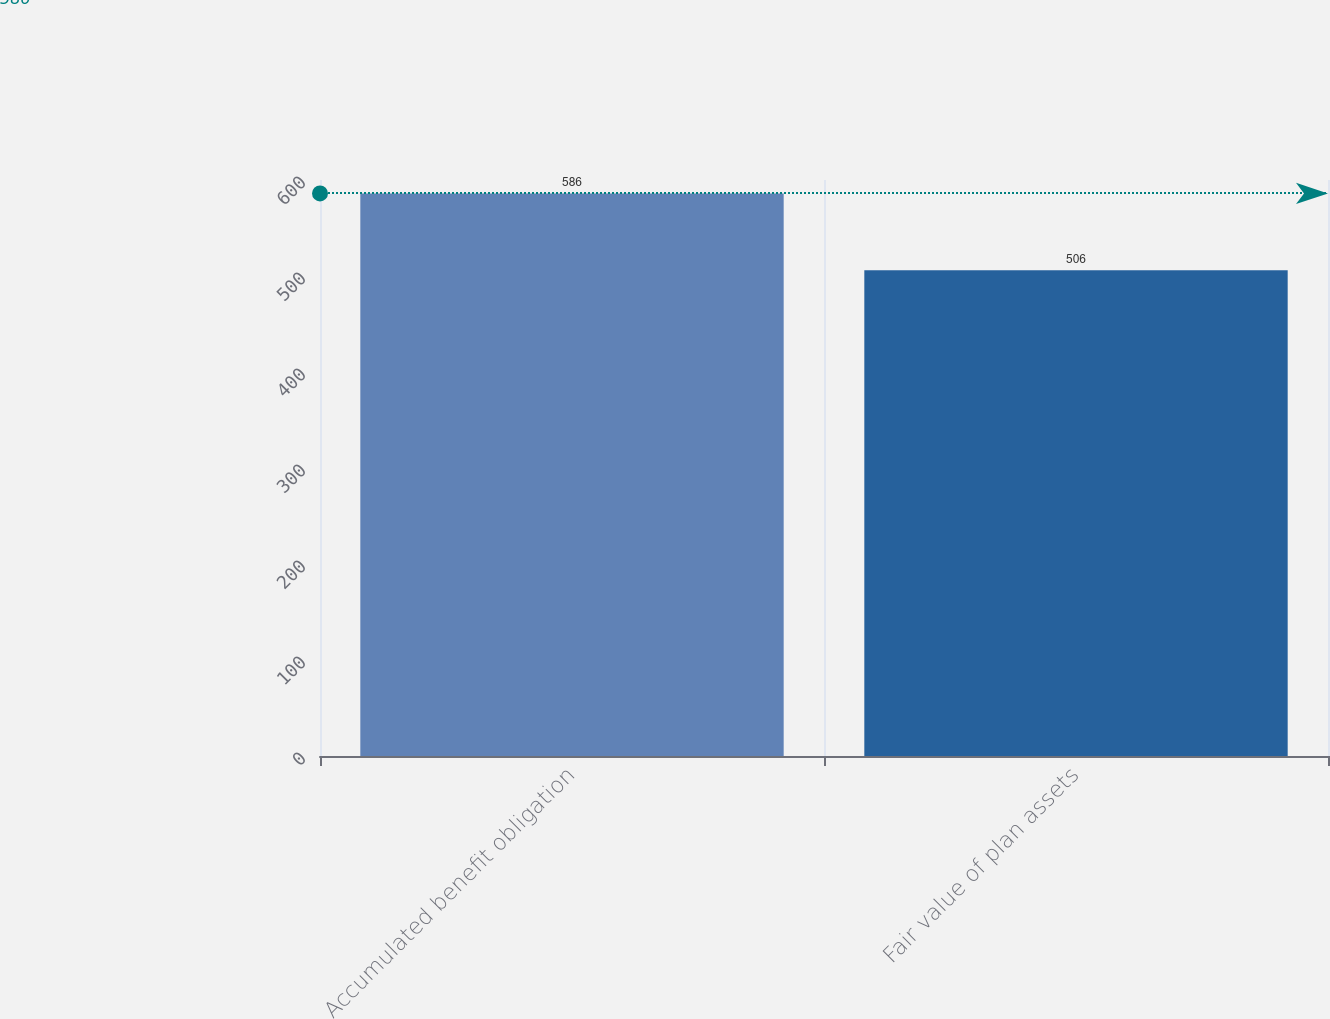Convert chart. <chart><loc_0><loc_0><loc_500><loc_500><bar_chart><fcel>Accumulated benefit obligation<fcel>Fair value of plan assets<nl><fcel>586<fcel>506<nl></chart> 